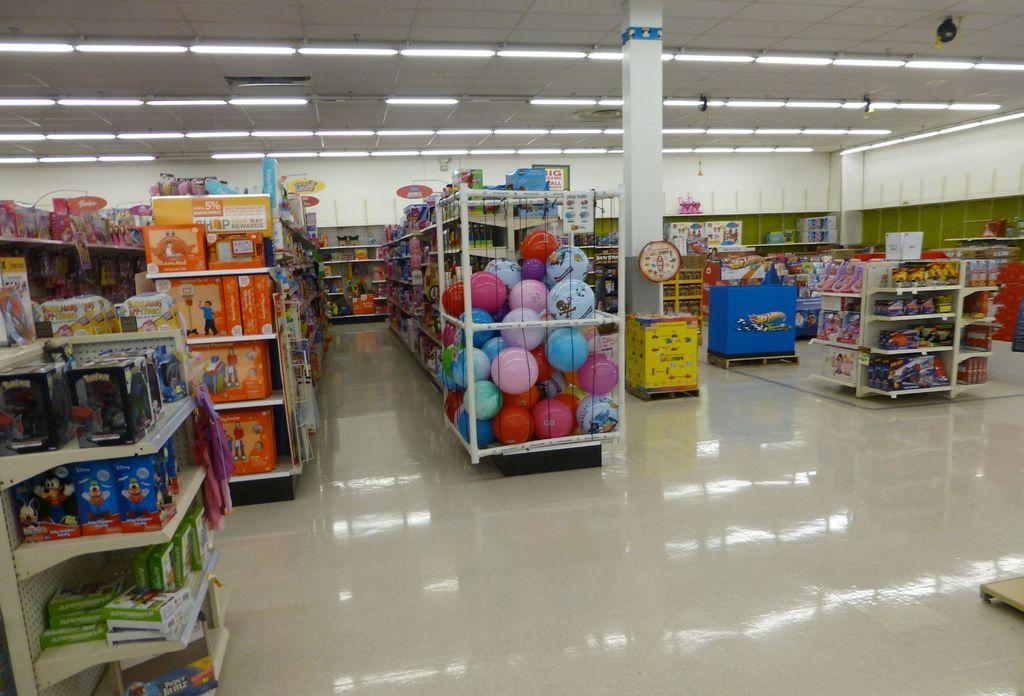What can be seen in the foreground of the image? There are racks in the foreground of the image. What is stored on the racks? The racks contain different types of items. Is there any architectural feature visible in the image? Yes, there is a pillar in the image. What can be seen on the roof at the top side of the image? There are lamps on the roof at the top side of the image. How does the flame on the lamps affect the order of the items on the racks? There is no flame present on the lamps in the image, and therefore it does not affect the order of the items on the racks. What answer can be found on the pillar in the image? There is no answer present on the pillar in the image; it is an architectural feature. 